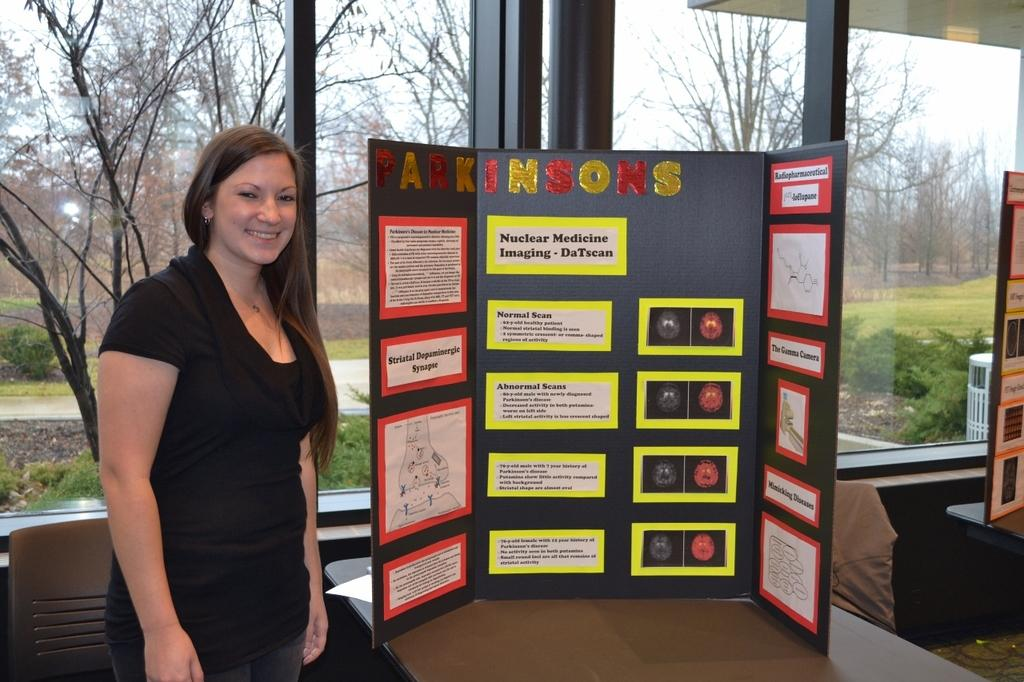What is the woman in the image doing? The woman is standing in the image and smiling. What can be seen on the paper in the image? The paper in the image has "PARKINSON'S" written on it. What is visible in the background of the image? There are trees and plants in the background of the image. What is the rate of the engine in the image? There is no engine present in the image, so it is not possible to determine its rate. 